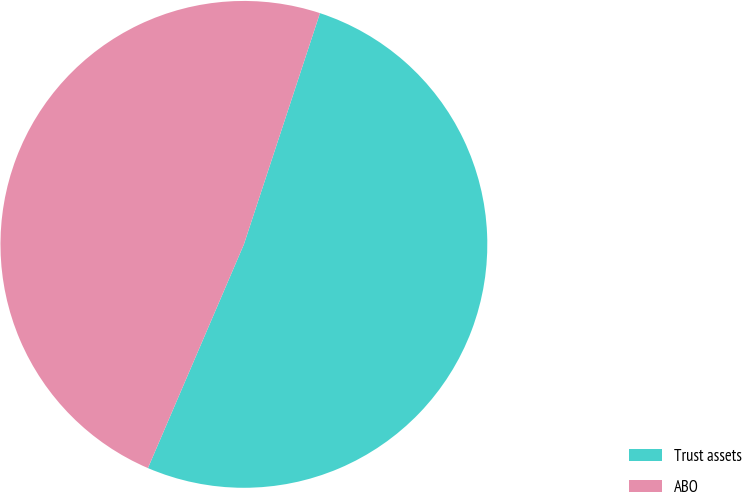<chart> <loc_0><loc_0><loc_500><loc_500><pie_chart><fcel>Trust assets<fcel>ABO<nl><fcel>51.39%<fcel>48.61%<nl></chart> 